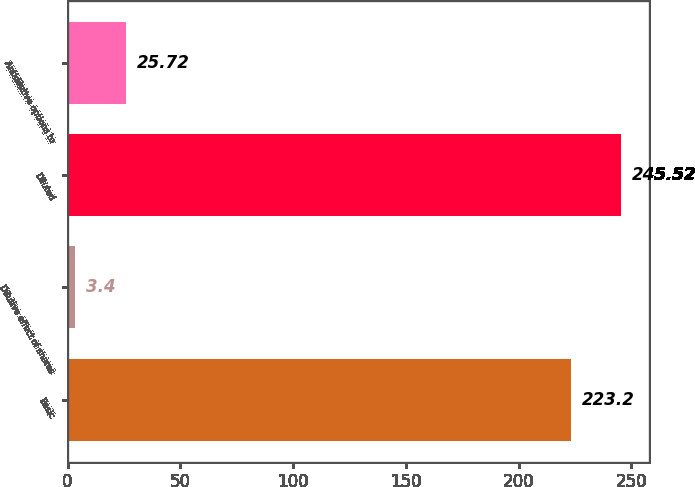<chart> <loc_0><loc_0><loc_500><loc_500><bar_chart><fcel>Basic<fcel>Dilutive effect of shares<fcel>Diluted<fcel>Antidilutive options to<nl><fcel>223.2<fcel>3.4<fcel>245.52<fcel>25.72<nl></chart> 